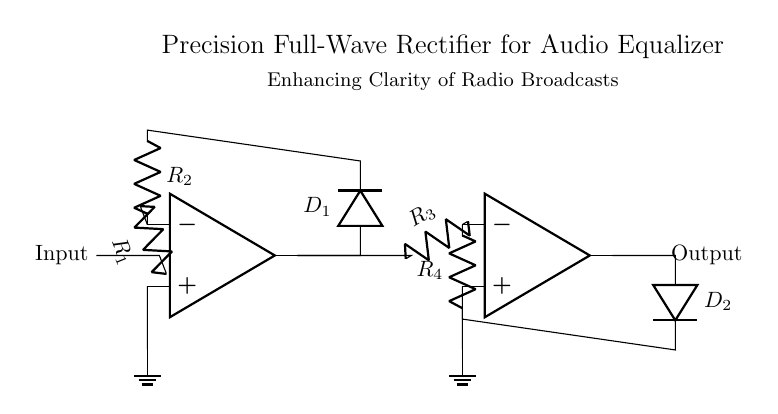What is the purpose of the operational amplifiers in this circuit? The operational amplifiers are used to amplify the input signal and facilitate the full-wave rectification process by providing the necessary conditions for the diodes to operate effectively.
Answer: Amplification and rectification What is the role of the resistors in the circuit? The resistors control the feedback and gain of the operational amplifiers, determining how the input signal is processed and ensuring stable operation within the circuit.
Answer: Control feedback and gain How many diodes are present in this circuit? There are two diodes in the circuit, named D1 and D2, which are used for the full-wave rectification.
Answer: Two What is the configuration of this rectifier? This is a precision full-wave rectifier configuration, which allows for accurate rectification of the AC input signal without significant voltage drop.
Answer: Precision full-wave What happens at the output of this rectifier when an AC signal is applied? The output will generate a rectified version of the input AC signal, allowing both halves of the waveform to contribute to the output, which enhances the clarity of the audio signal.
Answer: A rectified AC signal What is the significance of using a precision rectifier in an audio equalizer? A precision rectifier minimizes distortion and enhances the clarity of audio signals, which is crucial for accurately reproducing the descriptions of scenic landscapes in radio broadcasts.
Answer: Minimize distortion and enhance clarity 